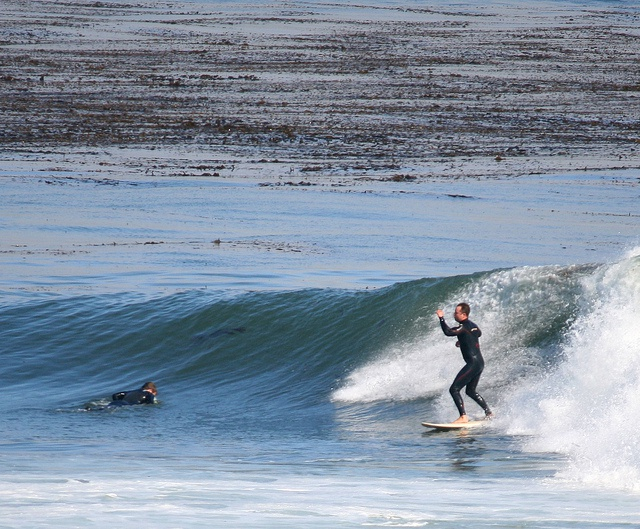Describe the objects in this image and their specific colors. I can see people in gray, black, and maroon tones, people in gray, black, navy, and blue tones, surfboard in gray, ivory, tan, and black tones, and surfboard in gray, blue, darkgray, and navy tones in this image. 